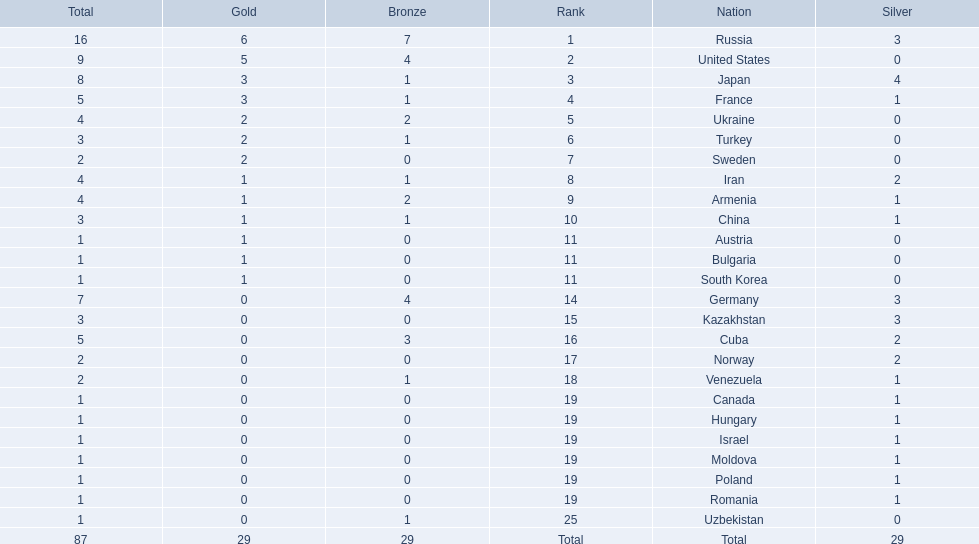Which nations are there? Russia, 6, United States, 5, Japan, 3, France, 3, Ukraine, 2, Turkey, 2, Sweden, 2, Iran, 1, Armenia, 1, China, 1, Austria, 1, Bulgaria, 1, South Korea, 1, Germany, 0, Kazakhstan, 0, Cuba, 0, Norway, 0, Venezuela, 0, Canada, 0, Hungary, 0, Israel, 0, Moldova, 0, Poland, 0, Romania, 0, Uzbekistan, 0. Which nations won gold? Russia, 6, United States, 5, Japan, 3, France, 3, Ukraine, 2, Turkey, 2, Sweden, 2, Iran, 1, Armenia, 1, China, 1, Austria, 1, Bulgaria, 1, South Korea, 1. How many golds did united states win? United States, 5. Which country has more than 5 gold medals? Russia, 6. What country is it? Russia. 